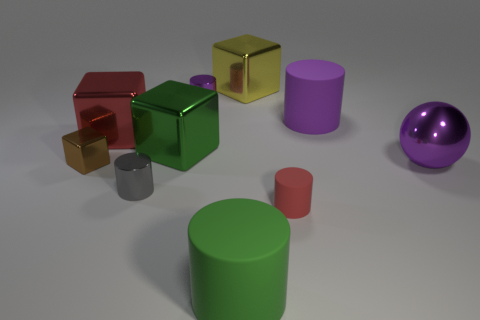Subtract all green cylinders. How many cylinders are left? 4 Subtract all tiny matte cylinders. How many cylinders are left? 4 Subtract all blue cylinders. Subtract all blue cubes. How many cylinders are left? 5 Subtract all spheres. How many objects are left? 9 Subtract 0 cyan cubes. How many objects are left? 10 Subtract all red things. Subtract all green metal blocks. How many objects are left? 7 Add 1 small gray cylinders. How many small gray cylinders are left? 2 Add 2 small cyan cylinders. How many small cyan cylinders exist? 2 